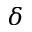Convert formula to latex. <formula><loc_0><loc_0><loc_500><loc_500>\delta</formula> 